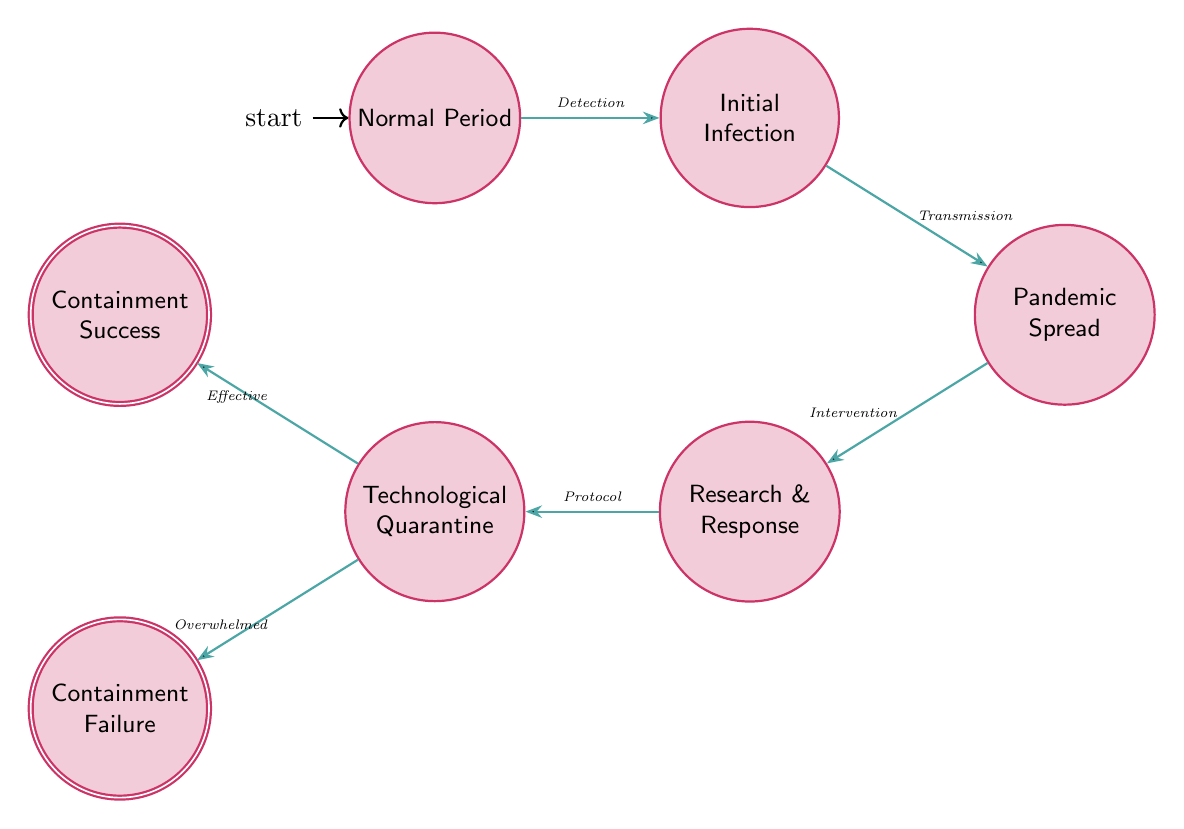What state immediately follows the Initial Infection? The flow diagram shows transitions between states. From the Initial Infection state, the next transition leads to the Pandemic Spread state, which is directly below and to the right of it.
Answer: Pandemic Spread How many states are in the diagram? By counting the individual nodes labeled as states in the diagram, there are a total of seven states depicted.
Answer: 7 What is the trigger that leads from Research and Response to Technological Quarantine? The transition from Research and Response to Technological Quarantine is activated by the trigger of developing quarantine protocols, which is explicitly stated in the diagram.
Answer: Protocol What is the outcome if containment measures fail? The diagram indicates that if containment measures fail, the state will transition to Containment Failure, leading to a situation similar to societal collapse as represented in historical pandemics.
Answer: Containment Failure Is Containment Success an accepting state? The description of the nodes in the diagram shows that Containment Success is one of the accepting states, which is indicated by its distinct visual representation as an accepting state.
Answer: Yes What transition occurs when there is a surge in infection cases? The diagram clearly indicates that a surge in infection cases results in the transition from the Pandemic Spread state to the Research and Response state for scientific intervention.
Answer: Intervention What are the two possible outcomes from the Technological Quarantine state? From the Technological Quarantine state, there are two possible outcomes: either a successful containment of the infection or a failure of containment, leading to distinct paths in the state machine.
Answer: Containment Success, Containment Failure What is the initial state of the diagram? The initial state, where society is functioning normally, is explicitly indicated as Normal Period in the diagram.
Answer: Normal Period 